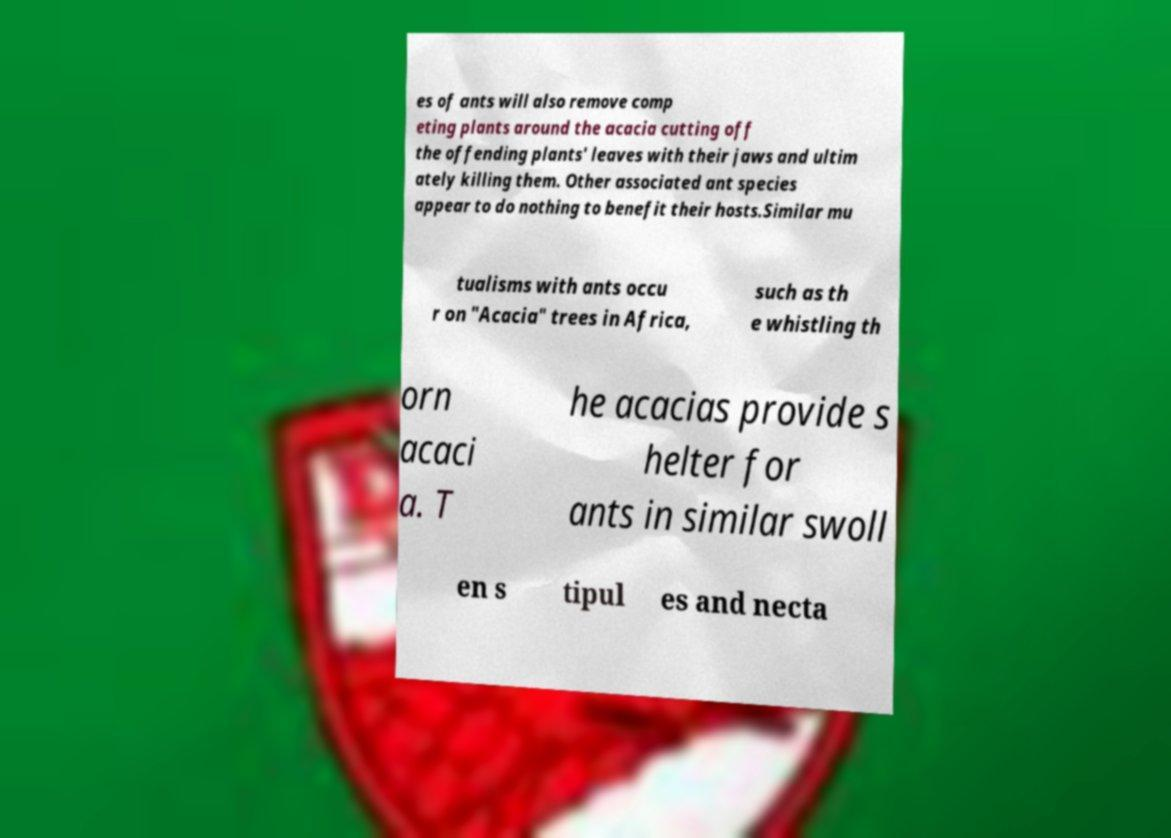Could you assist in decoding the text presented in this image and type it out clearly? es of ants will also remove comp eting plants around the acacia cutting off the offending plants' leaves with their jaws and ultim ately killing them. Other associated ant species appear to do nothing to benefit their hosts.Similar mu tualisms with ants occu r on "Acacia" trees in Africa, such as th e whistling th orn acaci a. T he acacias provide s helter for ants in similar swoll en s tipul es and necta 